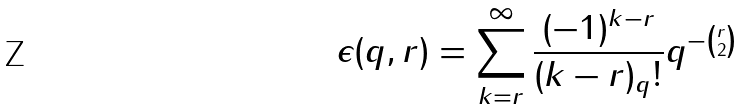Convert formula to latex. <formula><loc_0><loc_0><loc_500><loc_500>\epsilon ( q , r ) = \sum _ { k = r } ^ { \infty } \frac { ( - 1 ) ^ { k - r } } { ( k - r ) _ { q } ! } q ^ { - \binom { r } { 2 } }</formula> 